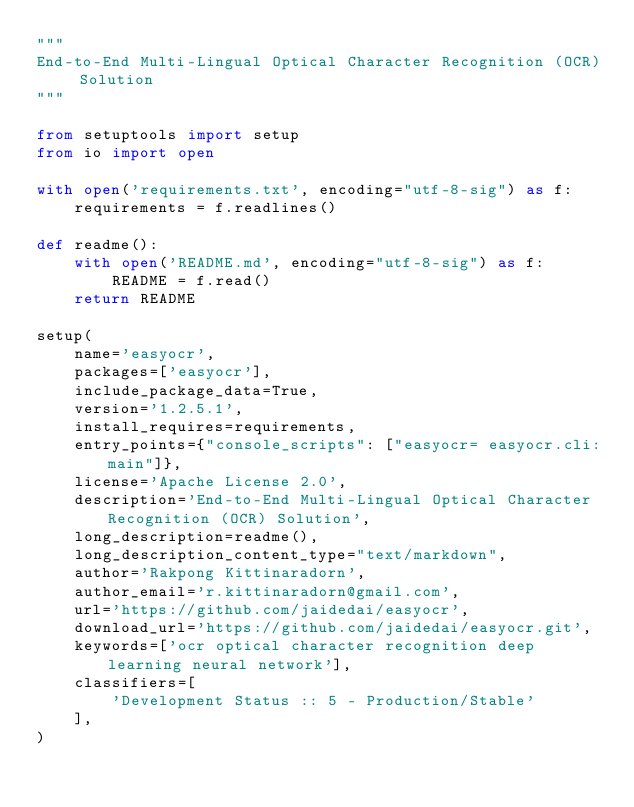Convert code to text. <code><loc_0><loc_0><loc_500><loc_500><_Python_>"""
End-to-End Multi-Lingual Optical Character Recognition (OCR) Solution
"""

from setuptools import setup
from io import open

with open('requirements.txt', encoding="utf-8-sig") as f:
    requirements = f.readlines()

def readme():
    with open('README.md', encoding="utf-8-sig") as f:
        README = f.read()
    return README

setup(
    name='easyocr',
    packages=['easyocr'],
    include_package_data=True,
    version='1.2.5.1',
    install_requires=requirements,
    entry_points={"console_scripts": ["easyocr= easyocr.cli:main"]},
    license='Apache License 2.0',
    description='End-to-End Multi-Lingual Optical Character Recognition (OCR) Solution',
    long_description=readme(),
    long_description_content_type="text/markdown",
    author='Rakpong Kittinaradorn',
    author_email='r.kittinaradorn@gmail.com',
    url='https://github.com/jaidedai/easyocr',
    download_url='https://github.com/jaidedai/easyocr.git',
    keywords=['ocr optical character recognition deep learning neural network'],
    classifiers=[
        'Development Status :: 5 - Production/Stable'
    ],
)
</code> 